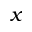Convert formula to latex. <formula><loc_0><loc_0><loc_500><loc_500>x</formula> 